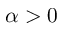<formula> <loc_0><loc_0><loc_500><loc_500>\alpha > 0</formula> 